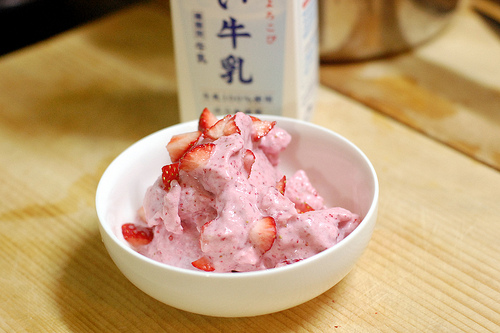<image>
Can you confirm if the ice cream is on the bowl? Yes. Looking at the image, I can see the ice cream is positioned on top of the bowl, with the bowl providing support. 